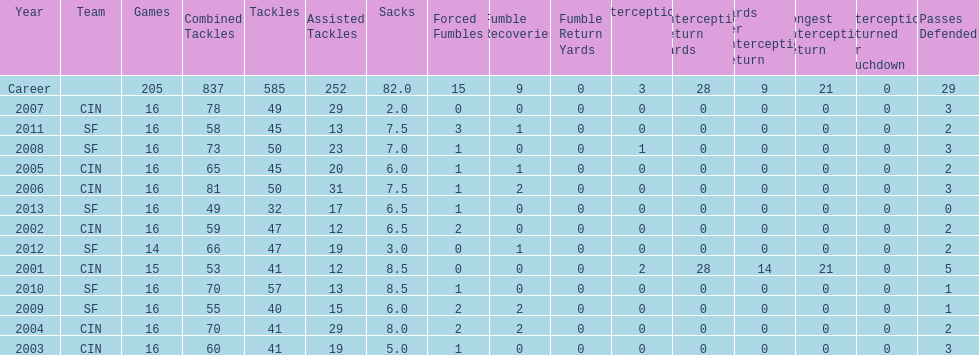I'm looking to parse the entire table for insights. Could you assist me with that? {'header': ['Year', 'Team', 'Games', 'Combined Tackles', 'Tackles', 'Assisted Tackles', 'Sacks', 'Forced Fumbles', 'Fumble Recoveries', 'Fumble Return Yards', 'Interceptions', 'Interception Return Yards', 'Yards per Interception Return', 'Longest Interception Return', 'Interceptions Returned for Touchdown', 'Passes Defended'], 'rows': [['Career', '', '205', '837', '585', '252', '82.0', '15', '9', '0', '3', '28', '9', '21', '0', '29'], ['2007', 'CIN', '16', '78', '49', '29', '2.0', '0', '0', '0', '0', '0', '0', '0', '0', '3'], ['2011', 'SF', '16', '58', '45', '13', '7.5', '3', '1', '0', '0', '0', '0', '0', '0', '2'], ['2008', 'SF', '16', '73', '50', '23', '7.0', '1', '0', '0', '1', '0', '0', '0', '0', '3'], ['2005', 'CIN', '16', '65', '45', '20', '6.0', '1', '1', '0', '0', '0', '0', '0', '0', '2'], ['2006', 'CIN', '16', '81', '50', '31', '7.5', '1', '2', '0', '0', '0', '0', '0', '0', '3'], ['2013', 'SF', '16', '49', '32', '17', '6.5', '1', '0', '0', '0', '0', '0', '0', '0', '0'], ['2002', 'CIN', '16', '59', '47', '12', '6.5', '2', '0', '0', '0', '0', '0', '0', '0', '2'], ['2012', 'SF', '14', '66', '47', '19', '3.0', '0', '1', '0', '0', '0', '0', '0', '0', '2'], ['2001', 'CIN', '15', '53', '41', '12', '8.5', '0', '0', '0', '2', '28', '14', '21', '0', '5'], ['2010', 'SF', '16', '70', '57', '13', '8.5', '1', '0', '0', '0', '0', '0', '0', '0', '1'], ['2009', 'SF', '16', '55', '40', '15', '6.0', '2', '2', '0', '0', '0', '0', '0', '0', '1'], ['2004', 'CIN', '16', '70', '41', '29', '8.0', '2', '2', '0', '0', '0', '0', '0', '0', '2'], ['2003', 'CIN', '16', '60', '41', '19', '5.0', '1', '0', '0', '0', '0', '0', '0', '0', '3']]} What is the average number of tackles this player has had over his career? 45. 